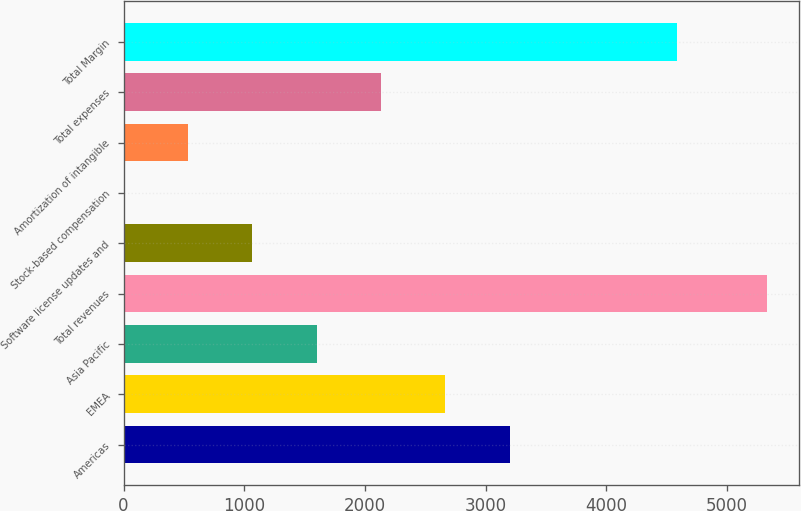<chart> <loc_0><loc_0><loc_500><loc_500><bar_chart><fcel>Americas<fcel>EMEA<fcel>Asia Pacific<fcel>Total revenues<fcel>Software license updates and<fcel>Stock-based compensation<fcel>Amortization of intangible<fcel>Total expenses<fcel>Total Margin<nl><fcel>3198.8<fcel>2666<fcel>1600.4<fcel>5330<fcel>1067.6<fcel>2<fcel>534.8<fcel>2133.2<fcel>4585<nl></chart> 